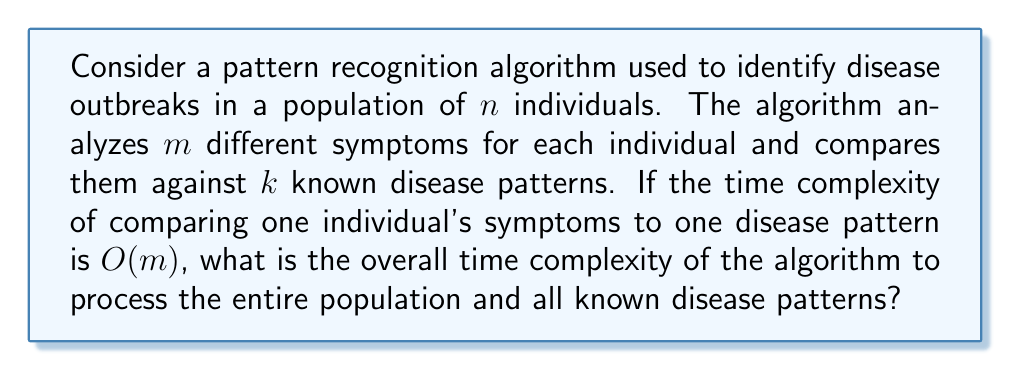Help me with this question. To solve this problem, let's break it down step-by-step:

1. For each individual, we need to analyze $m$ symptoms.
2. We need to compare these symptoms against $k$ known disease patterns.
3. The time complexity of comparing one individual's symptoms to one disease pattern is $O(m)$.
4. We need to perform this comparison for all $n$ individuals in the population.

Let's calculate the complexity:

1. For one individual and one disease pattern: $O(m)$
2. For one individual and all $k$ disease patterns: $O(m) * k = O(mk)$
3. For all $n$ individuals and all $k$ disease patterns: $O(mk) * n = O(nmk)$

Therefore, the overall time complexity of the algorithm is $O(nmk)$.

This cubic time complexity indicates that the algorithm's running time grows rapidly as the number of individuals, symptoms, or known disease patterns increases. In the context of epidemiology and disease outbreak identification, this complexity suggests that the algorithm may become computationally expensive for large populations or when analyzing a large number of symptoms and disease patterns.
Answer: The overall time complexity of the pattern recognition algorithm is $O(nmk)$, where $n$ is the number of individuals, $m$ is the number of symptoms analyzed per individual, and $k$ is the number of known disease patterns. 